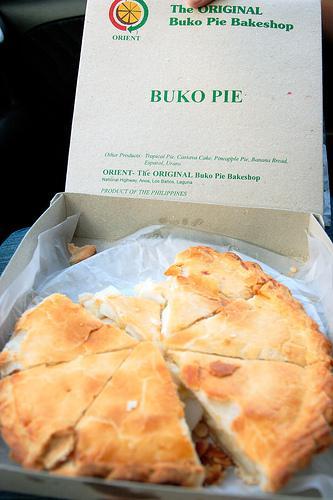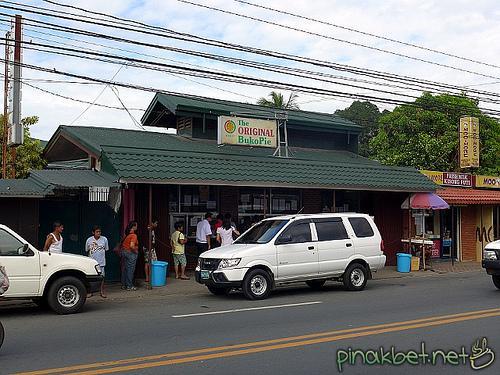The first image is the image on the left, the second image is the image on the right. Evaluate the accuracy of this statement regarding the images: "In at least one image there is a bunko pie missing at least one slice.". Is it true? Answer yes or no. Yes. The first image is the image on the left, the second image is the image on the right. Evaluate the accuracy of this statement regarding the images: "A pie is in an open box.". Is it true? Answer yes or no. Yes. 